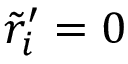<formula> <loc_0><loc_0><loc_500><loc_500>\tilde { r } _ { i } ^ { \prime } = 0</formula> 